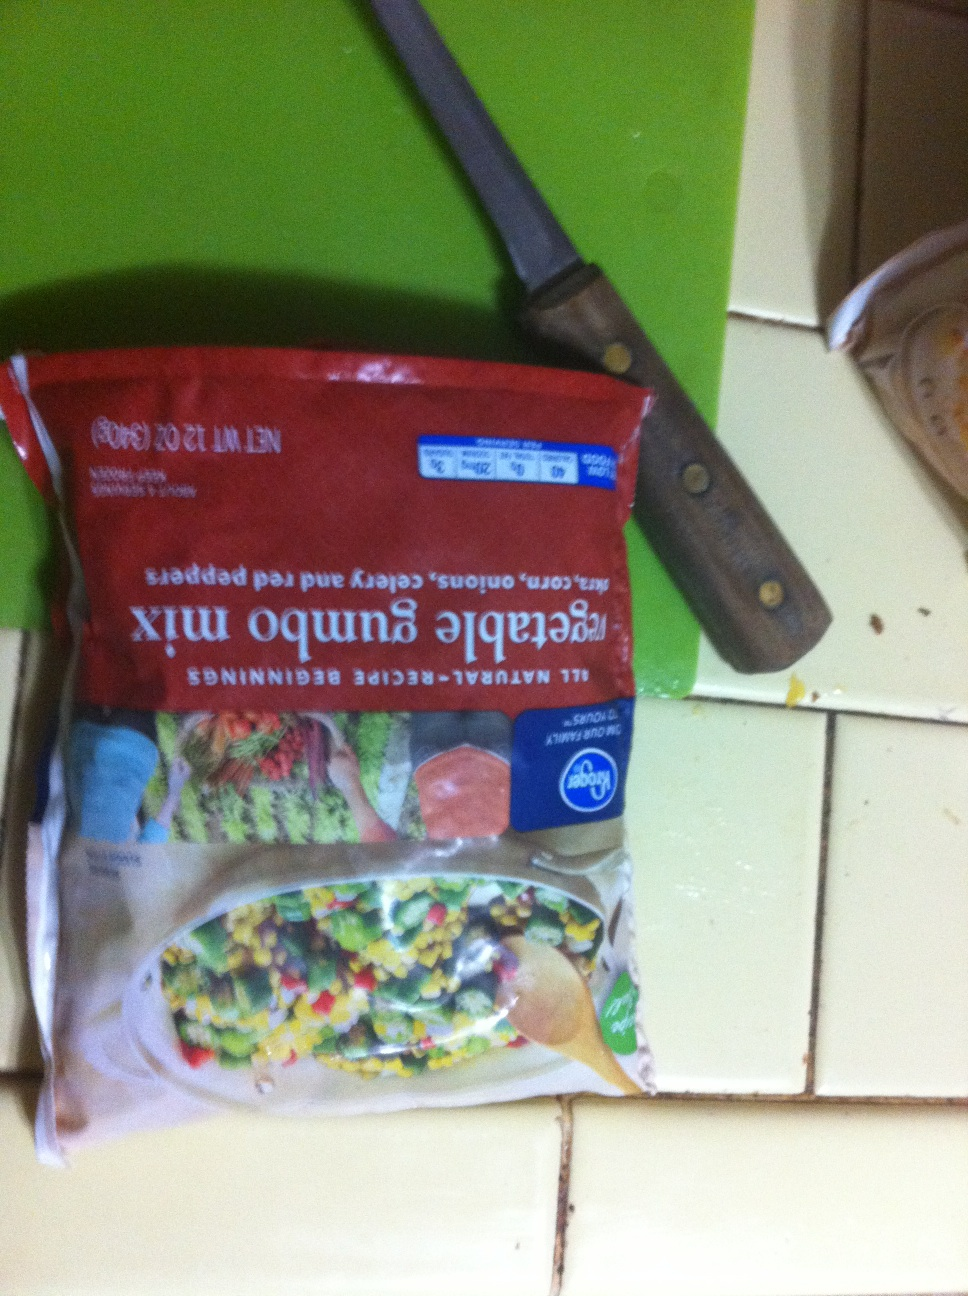If this vegetable mix were to be used in a cooking competition, what unique dish could a chef create to impress the judges? In a cooking competition, a chef could use this vegetable gumbo mix to create a 'Gumbo Risotto'. This dish would combine the rich, hearty flavors of traditional gumbo with the creamy texture of risotto. The chef would start by sautéing the vegetable mix with garlic and spices, then gradually add arborio rice and broth, stirring continuously until the rice reaches a creamy consistency. To elevate the dish, the chef might add some freshly caught shrimp and a touch of smoked paprika, garnishing it with finely chopped parsley and a sprinkle of parmesan cheese. The judges would be impressed by this innovative fusion of cuisine! 